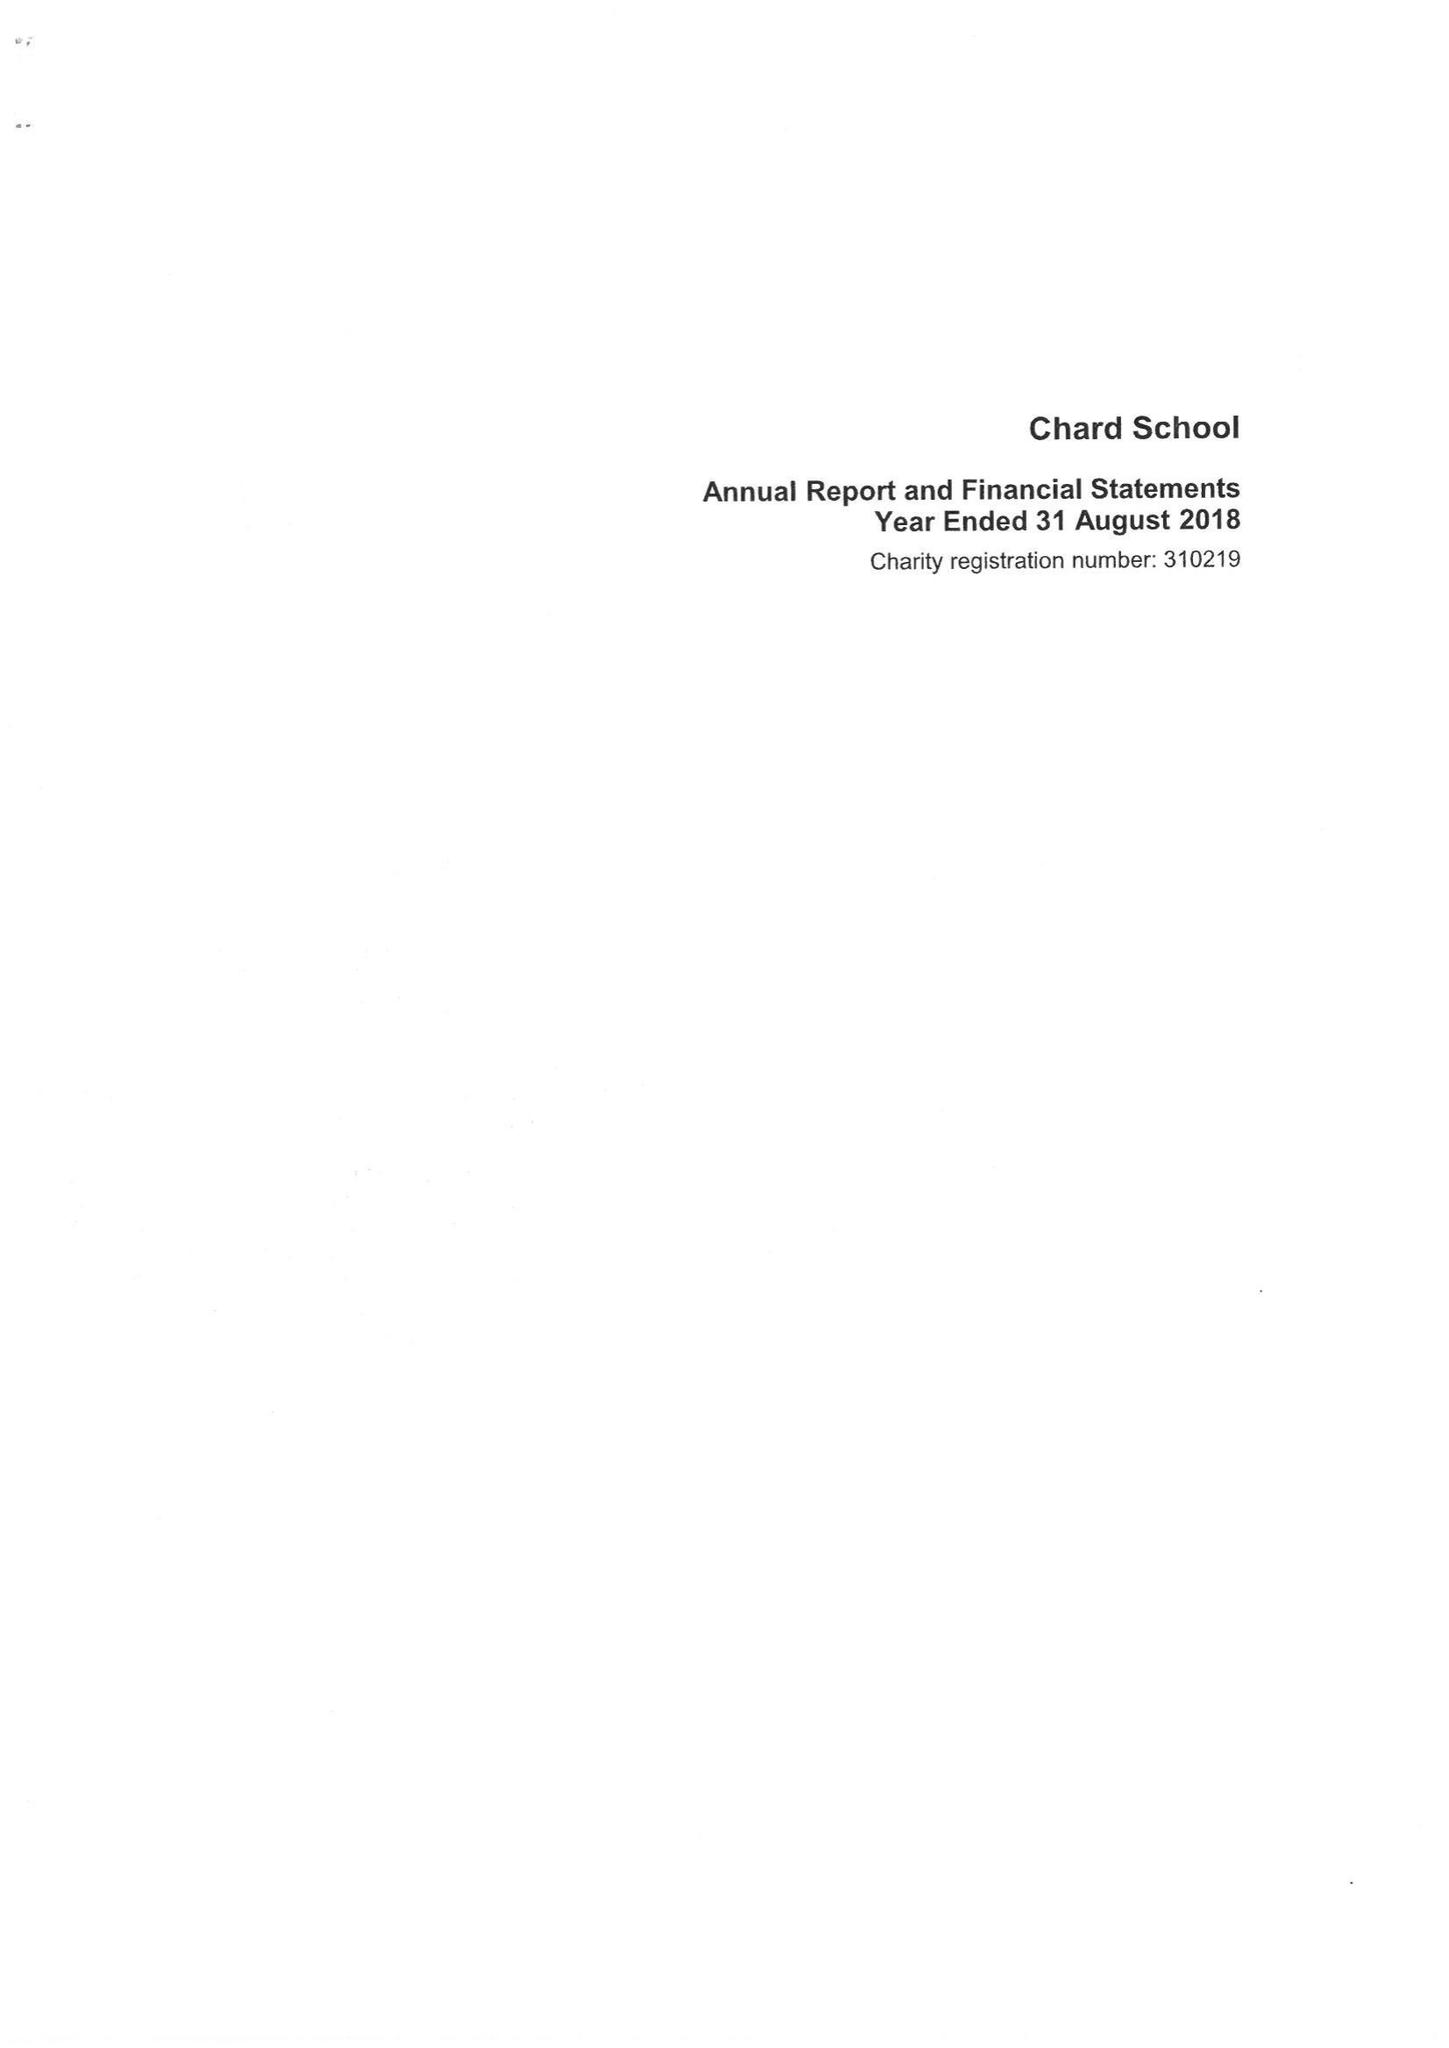What is the value for the address__postcode?
Answer the question using a single word or phrase. TA20 1QA 